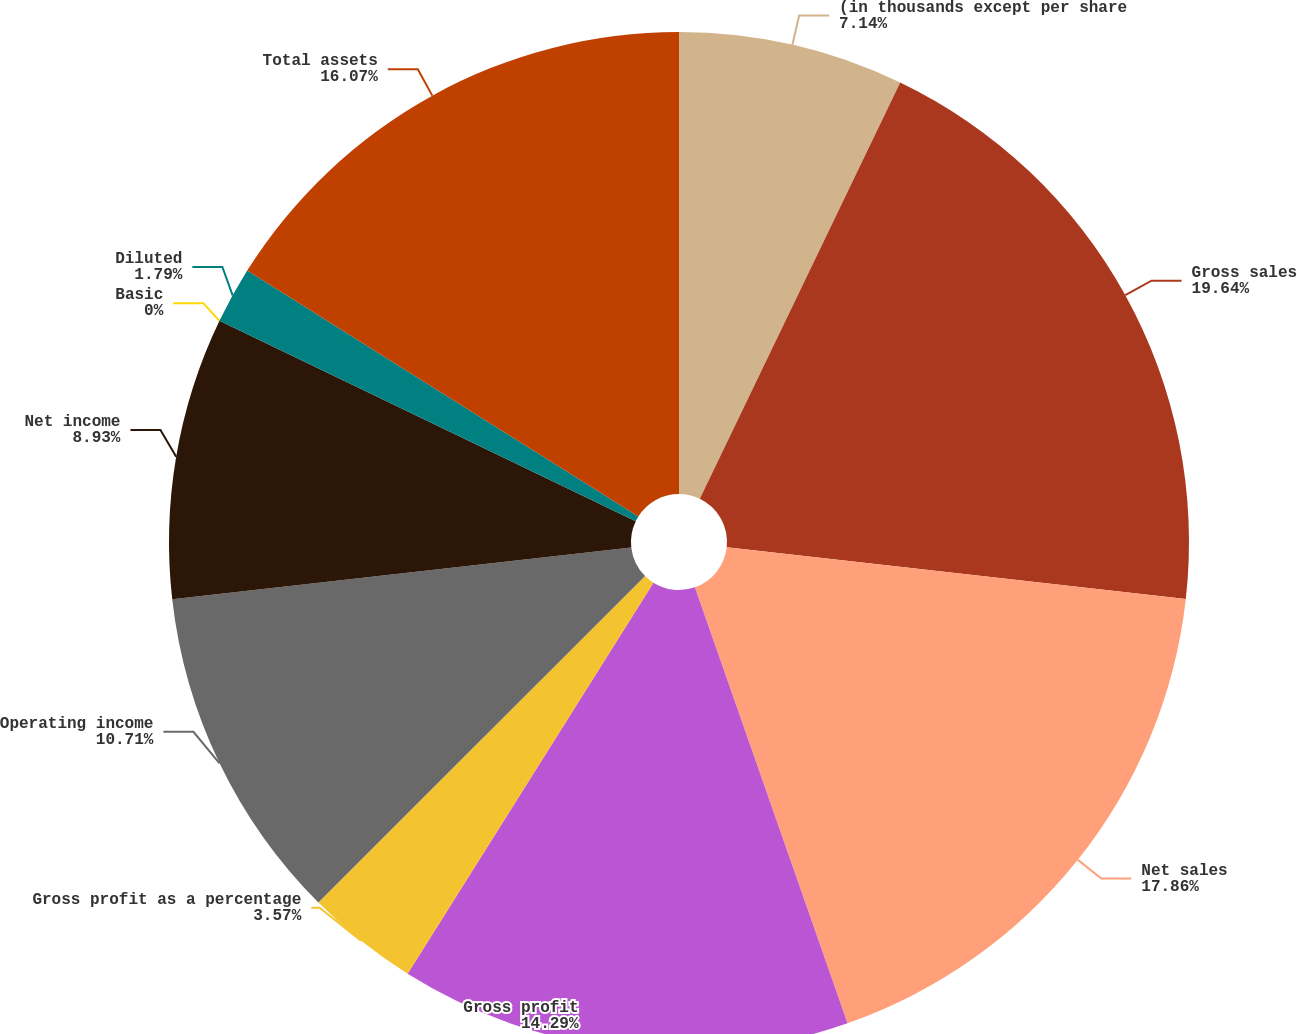<chart> <loc_0><loc_0><loc_500><loc_500><pie_chart><fcel>(in thousands except per share<fcel>Gross sales<fcel>Net sales<fcel>Gross profit<fcel>Gross profit as a percentage<fcel>Operating income<fcel>Net income<fcel>Basic<fcel>Diluted<fcel>Total assets<nl><fcel>7.14%<fcel>19.64%<fcel>17.86%<fcel>14.29%<fcel>3.57%<fcel>10.71%<fcel>8.93%<fcel>0.0%<fcel>1.79%<fcel>16.07%<nl></chart> 